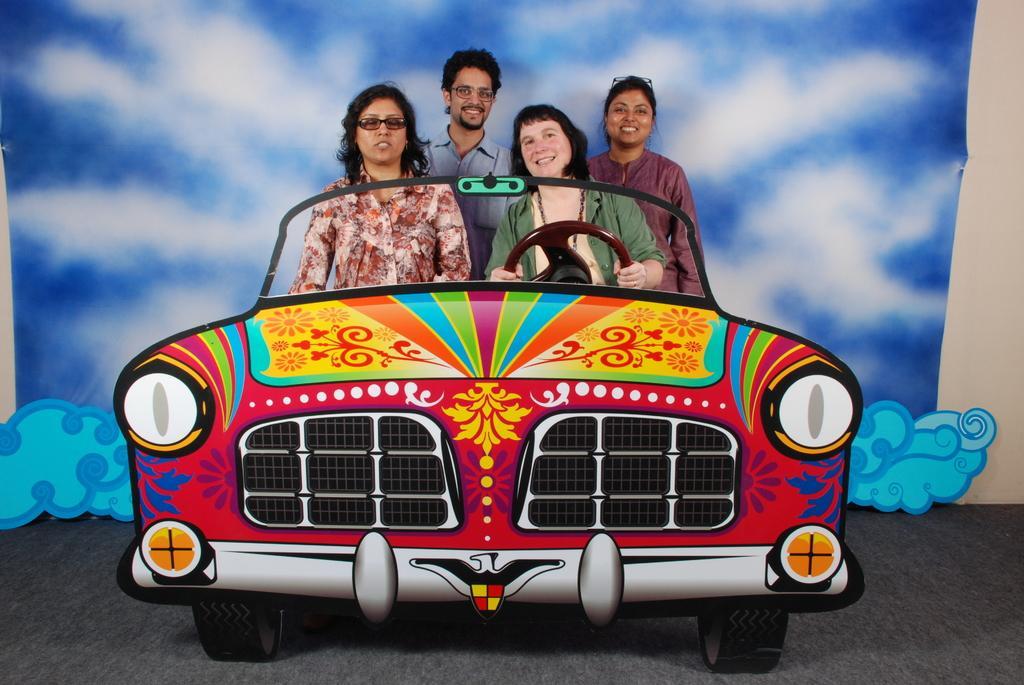Please provide a concise description of this image. In the given image we can see four people, three girls and a boy. This is a car. This is a staring part. These are the tires. 